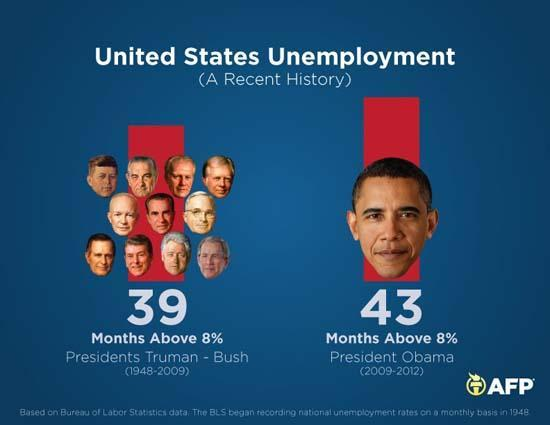For how many months did unemployment go above 8% during the period 1948-2009?
Answer the question with a short phrase. 39 For how many months did unemployment go above 8% during the term  of President Obama? 43 What is the presidential term of President Obama shown in this image? 2009-2012 